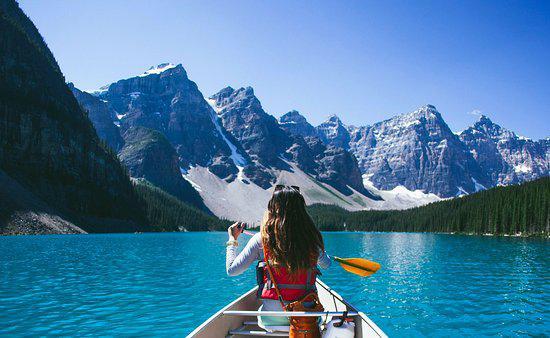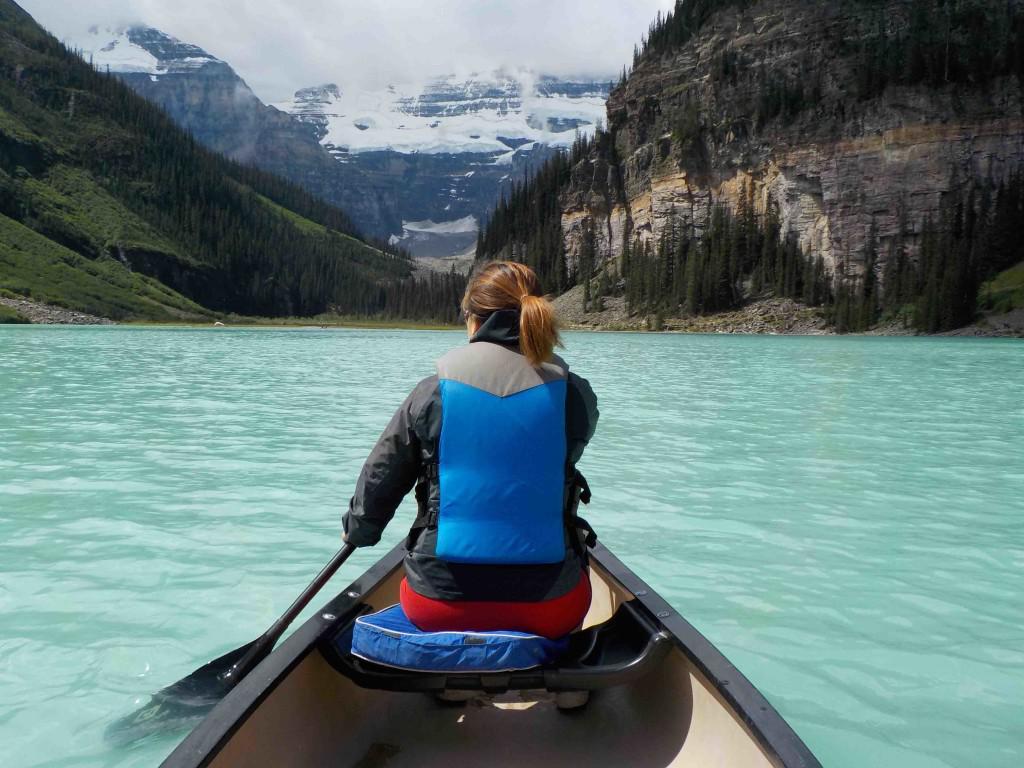The first image is the image on the left, the second image is the image on the right. Assess this claim about the two images: "In one image there is a red boat with two people and the other image is a empty boat floating on the water.". Correct or not? Answer yes or no. No. The first image is the image on the left, the second image is the image on the right. Analyze the images presented: Is the assertion "There is only one red canoe." valid? Answer yes or no. No. 